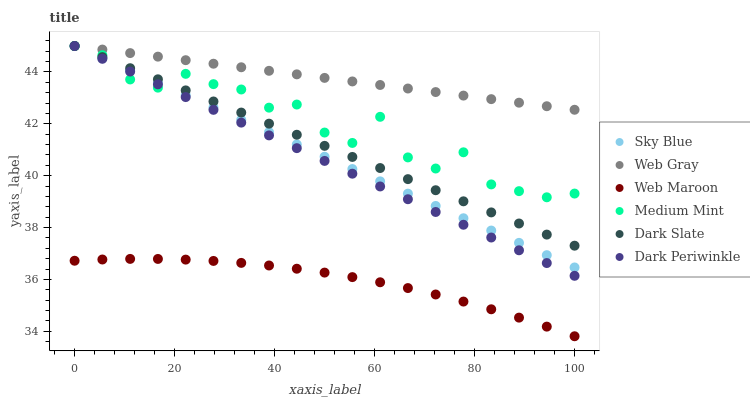Does Web Maroon have the minimum area under the curve?
Answer yes or no. Yes. Does Web Gray have the maximum area under the curve?
Answer yes or no. Yes. Does Web Gray have the minimum area under the curve?
Answer yes or no. No. Does Web Maroon have the maximum area under the curve?
Answer yes or no. No. Is Web Gray the smoothest?
Answer yes or no. Yes. Is Medium Mint the roughest?
Answer yes or no. Yes. Is Web Maroon the smoothest?
Answer yes or no. No. Is Web Maroon the roughest?
Answer yes or no. No. Does Web Maroon have the lowest value?
Answer yes or no. Yes. Does Web Gray have the lowest value?
Answer yes or no. No. Does Dark Periwinkle have the highest value?
Answer yes or no. Yes. Does Web Maroon have the highest value?
Answer yes or no. No. Is Web Maroon less than Medium Mint?
Answer yes or no. Yes. Is Dark Slate greater than Web Maroon?
Answer yes or no. Yes. Does Dark Slate intersect Medium Mint?
Answer yes or no. Yes. Is Dark Slate less than Medium Mint?
Answer yes or no. No. Is Dark Slate greater than Medium Mint?
Answer yes or no. No. Does Web Maroon intersect Medium Mint?
Answer yes or no. No. 